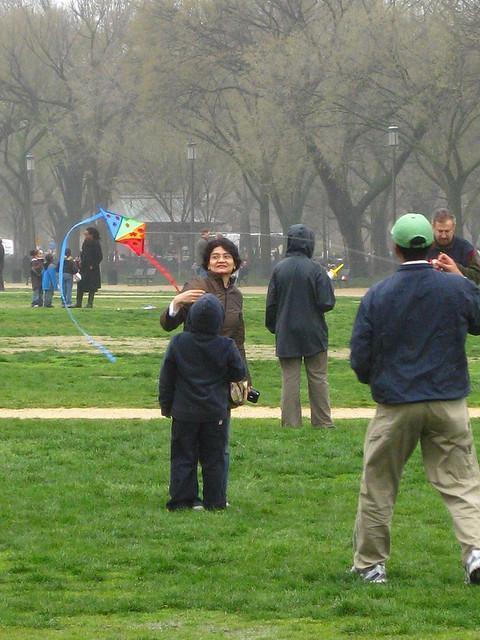How many people are there?
Give a very brief answer. 4. How many forks are there?
Give a very brief answer. 0. 